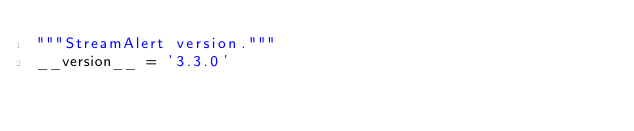Convert code to text. <code><loc_0><loc_0><loc_500><loc_500><_Python_>"""StreamAlert version."""
__version__ = '3.3.0'
</code> 